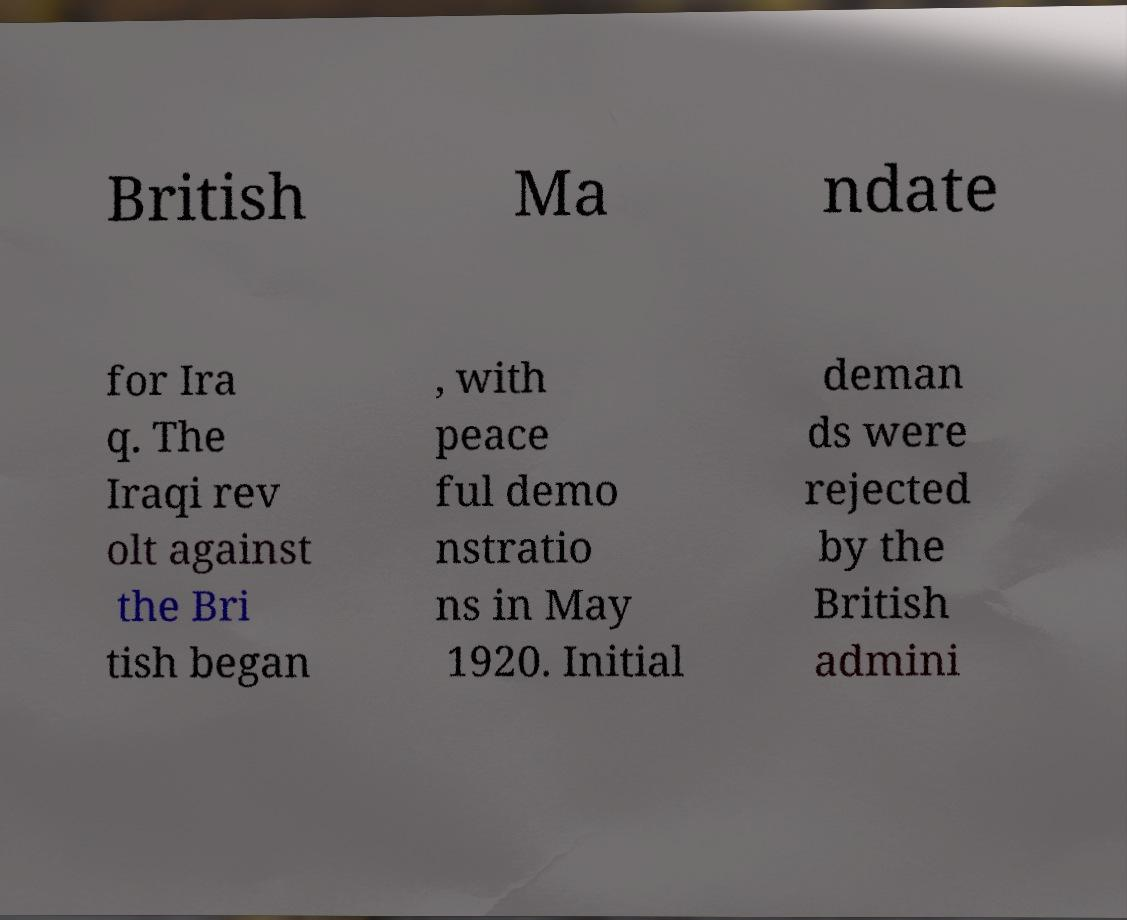There's text embedded in this image that I need extracted. Can you transcribe it verbatim? British Ma ndate for Ira q. The Iraqi rev olt against the Bri tish began , with peace ful demo nstratio ns in May 1920. Initial deman ds were rejected by the British admini 